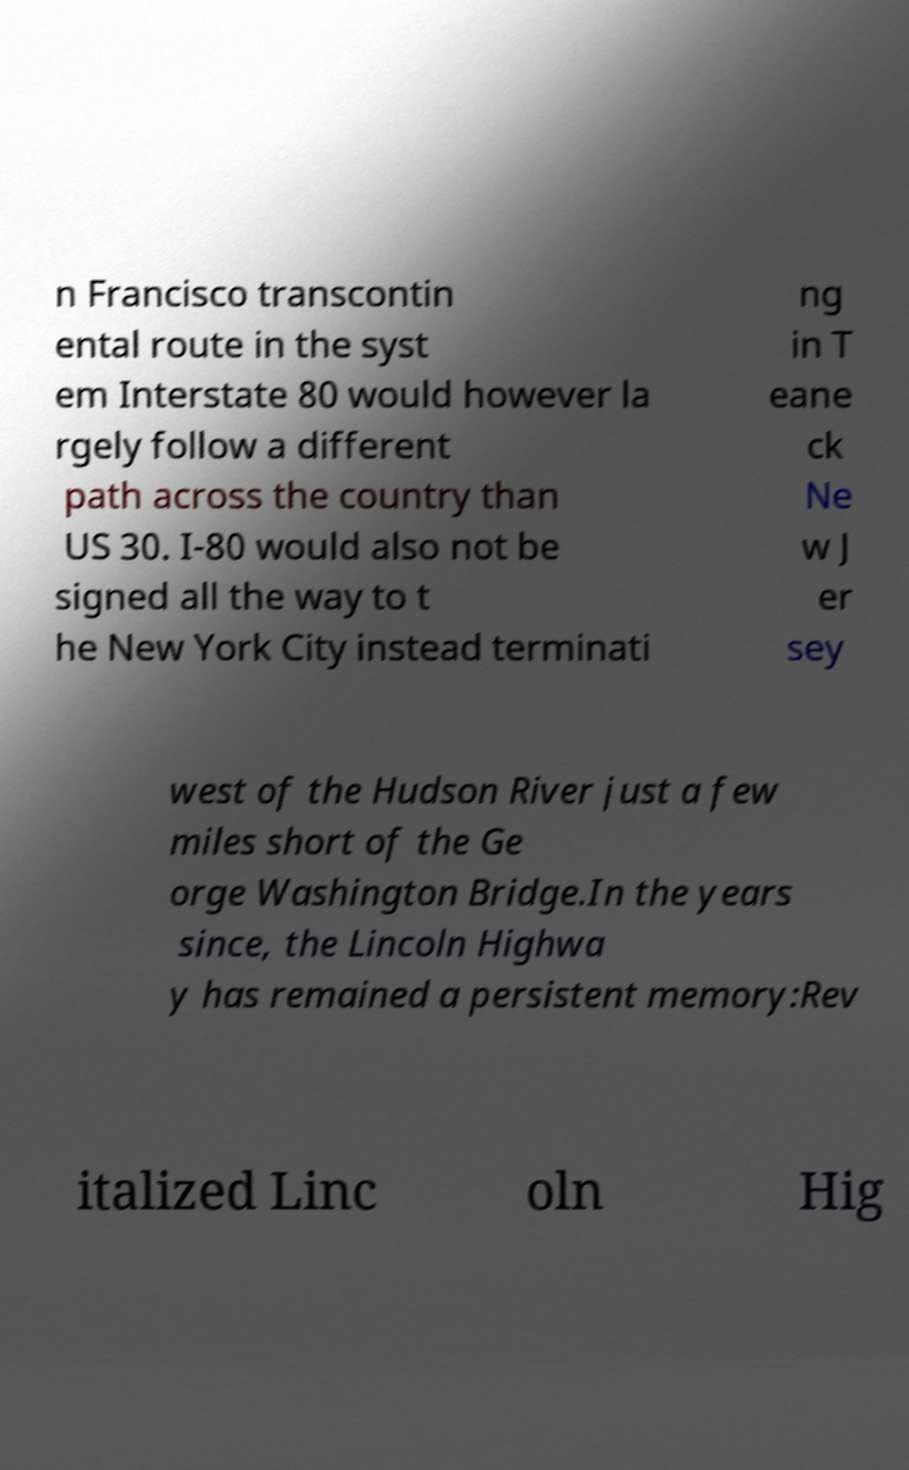Please identify and transcribe the text found in this image. n Francisco transcontin ental route in the syst em Interstate 80 would however la rgely follow a different path across the country than US 30. I-80 would also not be signed all the way to t he New York City instead terminati ng in T eane ck Ne w J er sey west of the Hudson River just a few miles short of the Ge orge Washington Bridge.In the years since, the Lincoln Highwa y has remained a persistent memory:Rev italized Linc oln Hig 